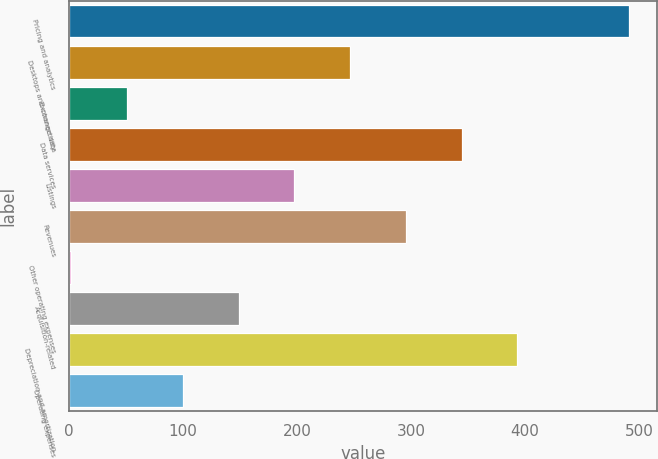Convert chart to OTSL. <chart><loc_0><loc_0><loc_500><loc_500><bar_chart><fcel>Pricing and analytics<fcel>Desktops and connectivity<fcel>Exchange data<fcel>Data services<fcel>Listings<fcel>Revenues<fcel>Other operating expenses<fcel>Acquisition-related<fcel>Depreciation and amortization<fcel>Operating expenses<nl><fcel>491<fcel>246.5<fcel>50.9<fcel>344.3<fcel>197.6<fcel>295.4<fcel>2<fcel>148.7<fcel>393.2<fcel>99.8<nl></chart> 